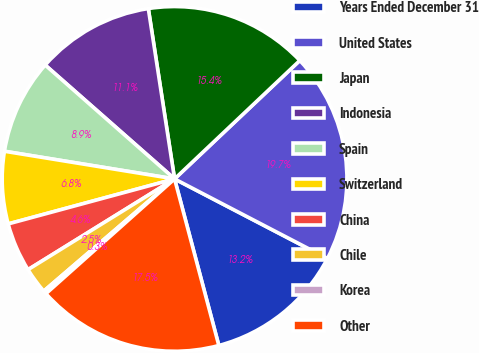Convert chart to OTSL. <chart><loc_0><loc_0><loc_500><loc_500><pie_chart><fcel>Years Ended December 31<fcel>United States<fcel>Japan<fcel>Indonesia<fcel>Spain<fcel>Switzerland<fcel>China<fcel>Chile<fcel>Korea<fcel>Other<nl><fcel>13.23%<fcel>19.69%<fcel>15.38%<fcel>11.08%<fcel>8.92%<fcel>6.77%<fcel>4.62%<fcel>2.46%<fcel>0.31%<fcel>17.54%<nl></chart> 